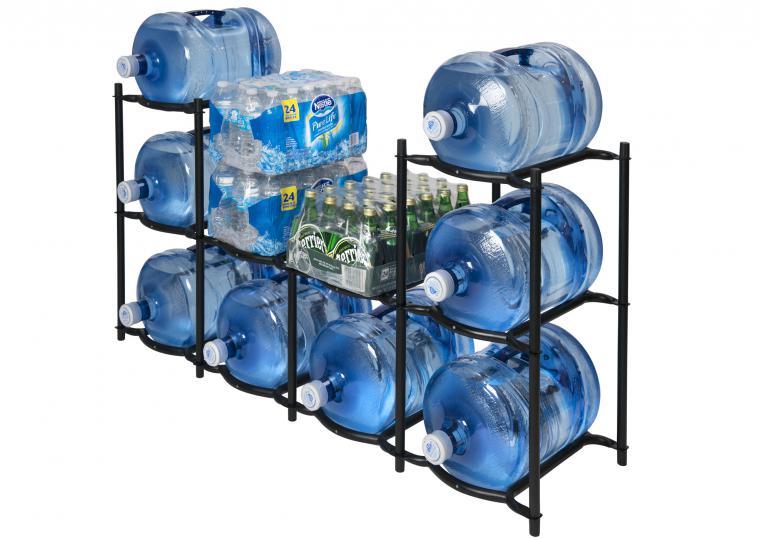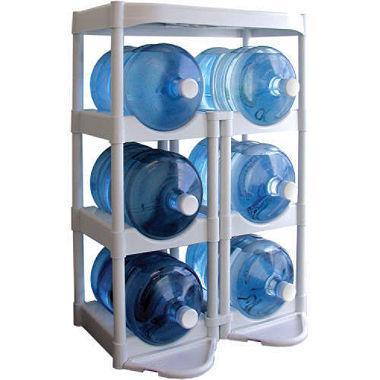The first image is the image on the left, the second image is the image on the right. Considering the images on both sides, is "Every image has a fully stocked tower of blue water jugs with at least three levels." valid? Answer yes or no. Yes. The first image is the image on the left, the second image is the image on the right. Assess this claim about the two images: "An image contains a rack holding large water bottles.". Correct or not? Answer yes or no. Yes. 